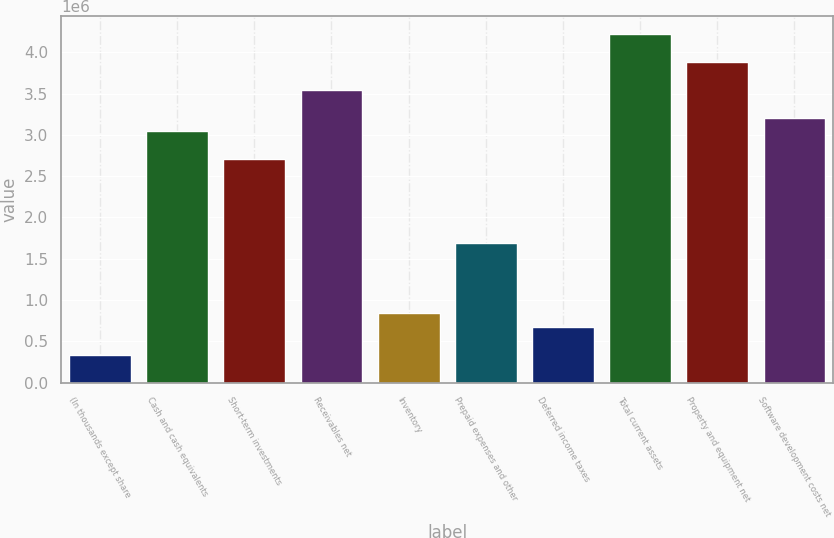Convert chart to OTSL. <chart><loc_0><loc_0><loc_500><loc_500><bar_chart><fcel>(In thousands except share<fcel>Cash and cash equivalents<fcel>Short-term investments<fcel>Receivables net<fcel>Inventory<fcel>Prepaid expenses and other<fcel>Deferred income taxes<fcel>Total current assets<fcel>Property and equipment net<fcel>Software development costs net<nl><fcel>338632<fcel>3.04128e+06<fcel>2.70345e+06<fcel>3.54803e+06<fcel>845378<fcel>1.68996e+06<fcel>676463<fcel>4.22369e+06<fcel>3.88586e+06<fcel>3.2102e+06<nl></chart> 